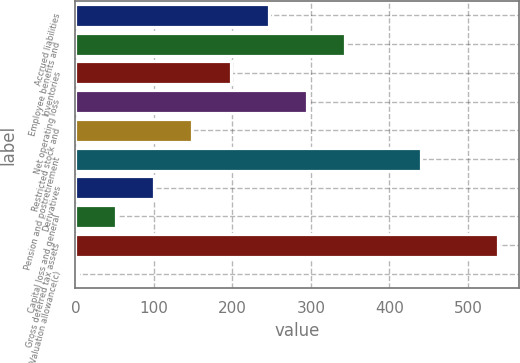Convert chart to OTSL. <chart><loc_0><loc_0><loc_500><loc_500><bar_chart><fcel>Accrued liabilities<fcel>Employee benefits and<fcel>Inventories<fcel>Net operating loss<fcel>Restricted stock and<fcel>Pension and postretirement<fcel>Derivatives<fcel>Capital loss and general<fcel>Gross deferred tax assets<fcel>Valuation allowance(c)<nl><fcel>246.3<fcel>343.58<fcel>197.66<fcel>294.94<fcel>149.02<fcel>440.86<fcel>100.38<fcel>51.74<fcel>538.14<fcel>3.1<nl></chart> 